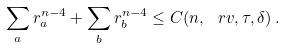<formula> <loc_0><loc_0><loc_500><loc_500>\sum _ { a } r _ { a } ^ { n - 4 } + \sum _ { b } r _ { b } ^ { n - 4 } \leq C ( n , \ r v , \tau , \delta ) \, .</formula> 